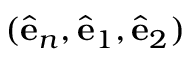Convert formula to latex. <formula><loc_0><loc_0><loc_500><loc_500>( { \hat { e } } _ { n } , { \hat { e } } _ { 1 } , { \hat { e } } _ { 2 } )</formula> 